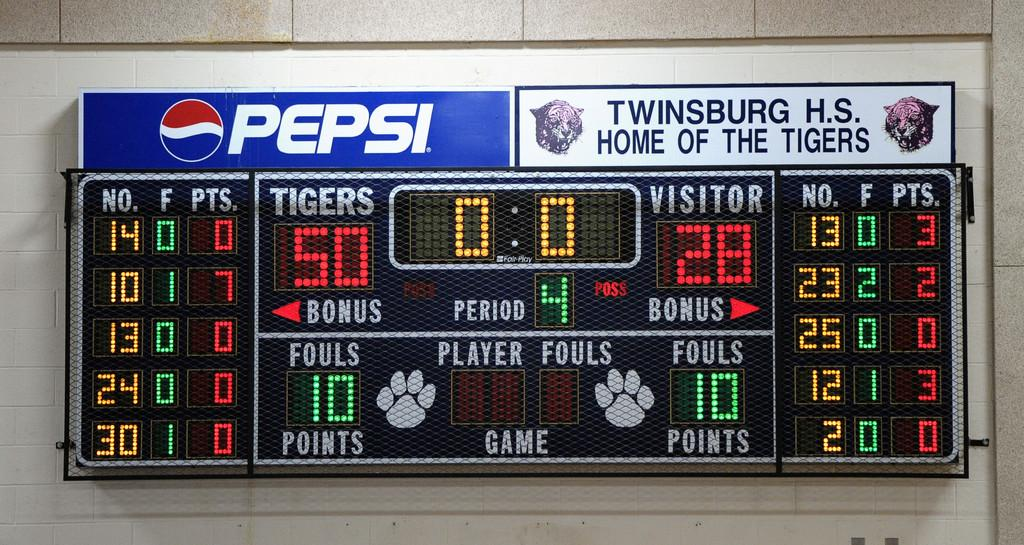<image>
Describe the image concisely. The team score board is sponsored by Pepsi 